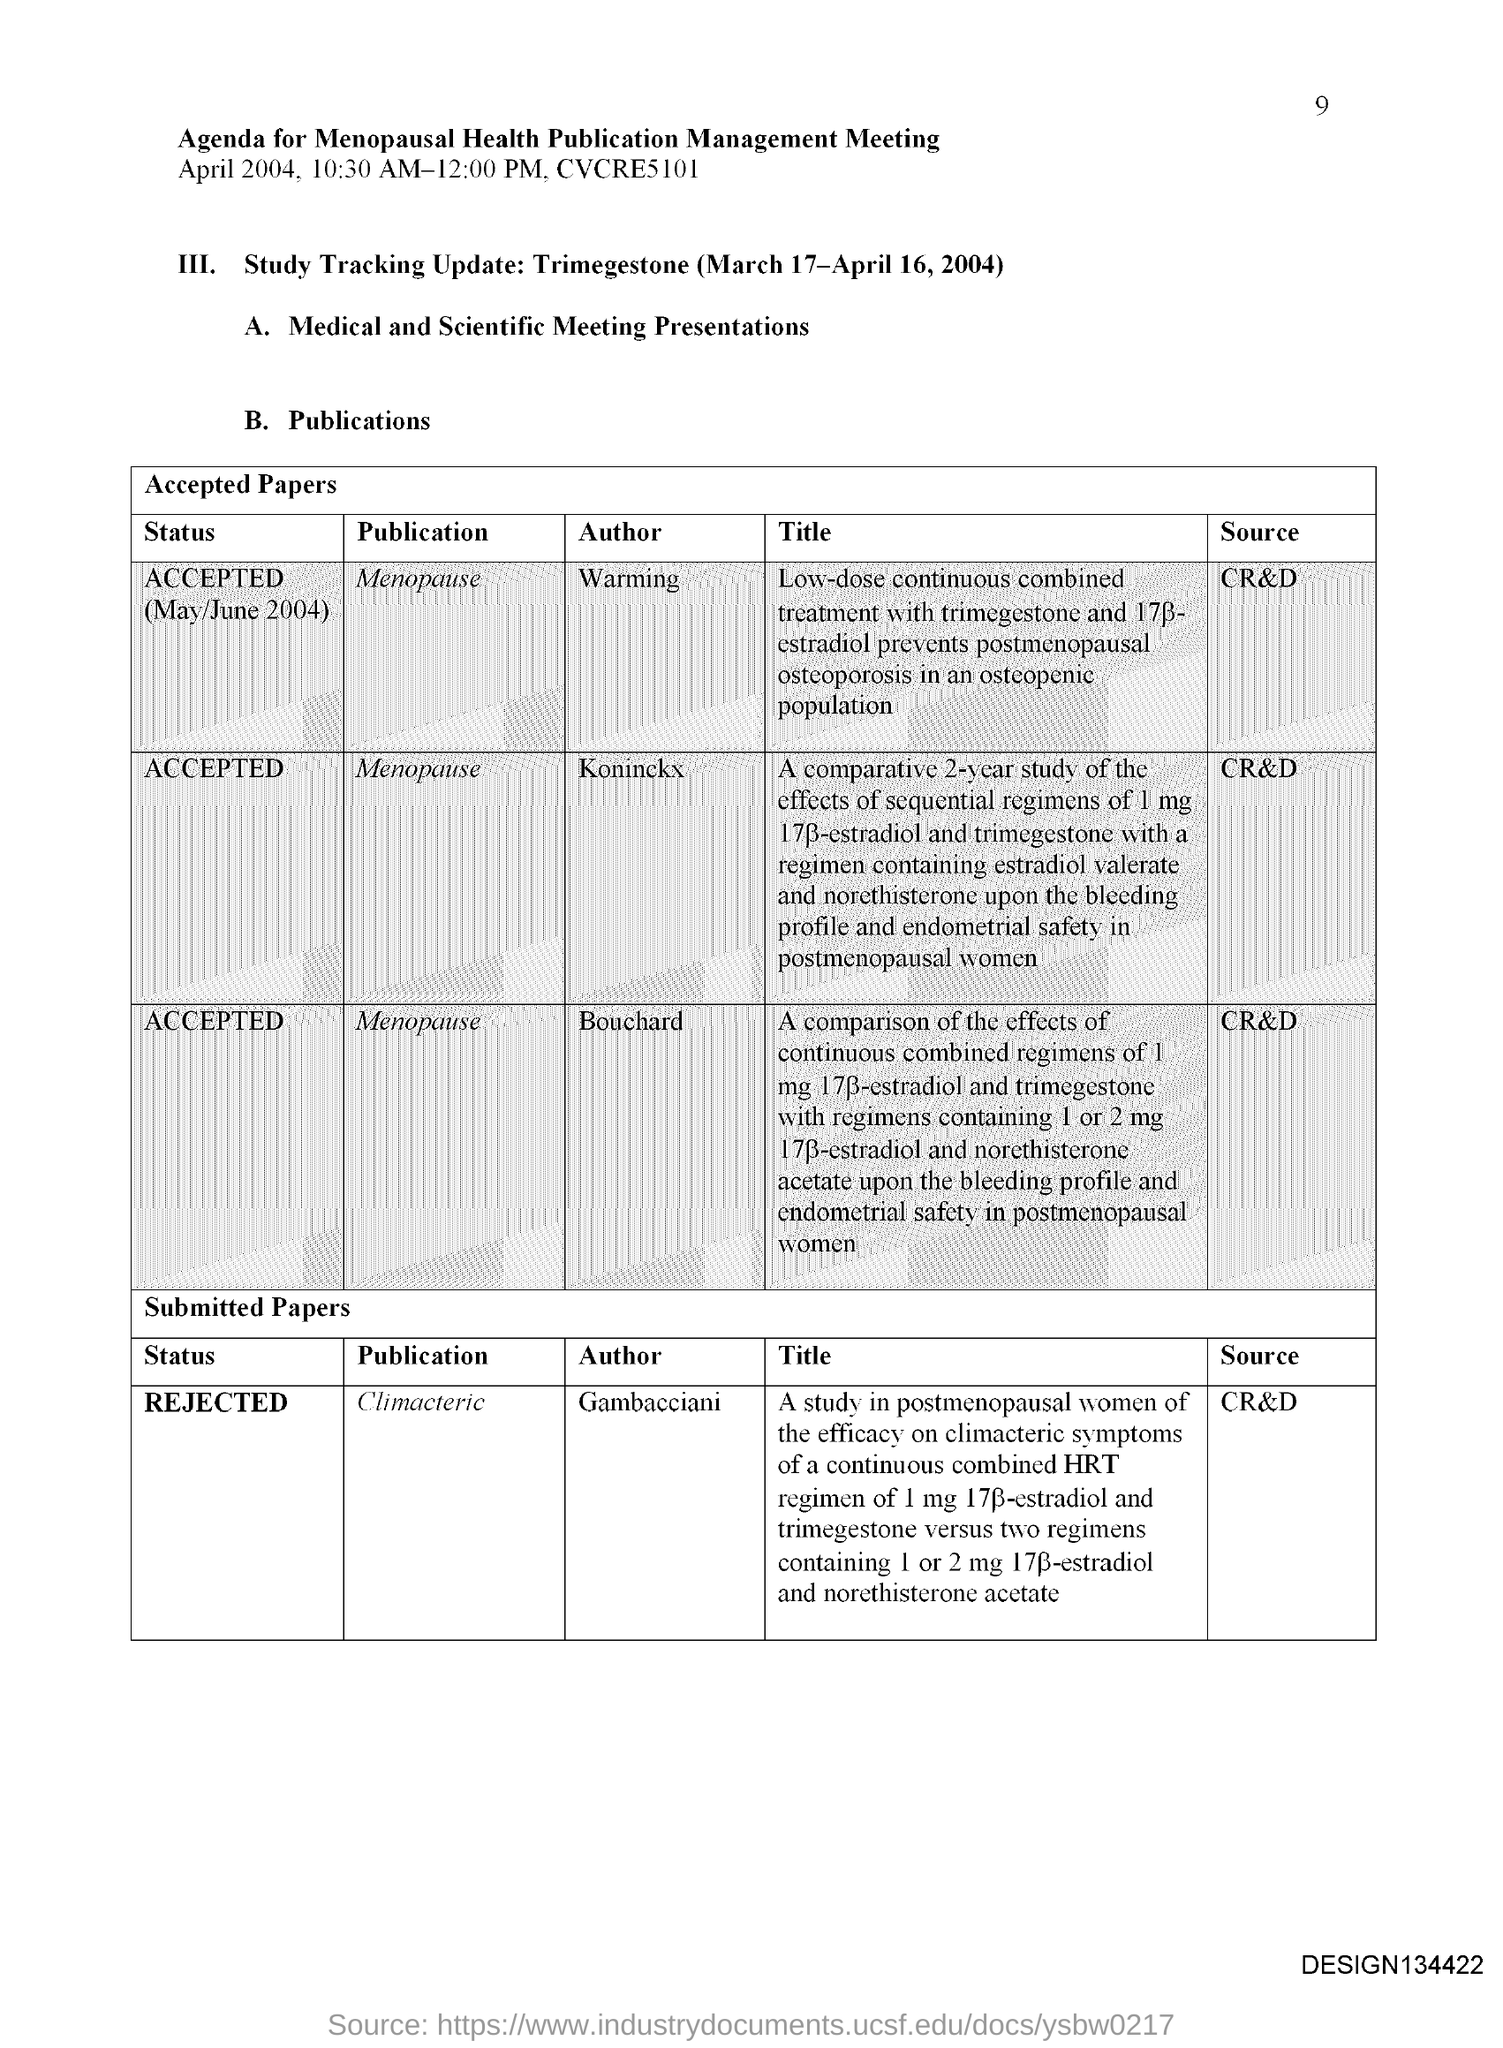What is the page no mentioned in this document?
Provide a short and direct response. 9. 